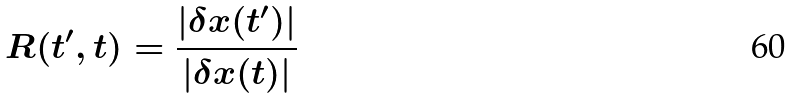Convert formula to latex. <formula><loc_0><loc_0><loc_500><loc_500>R ( t ^ { \prime } , t ) = \frac { | \delta { x } ( t ^ { \prime } ) | } { | \delta { x } ( t ) | }</formula> 